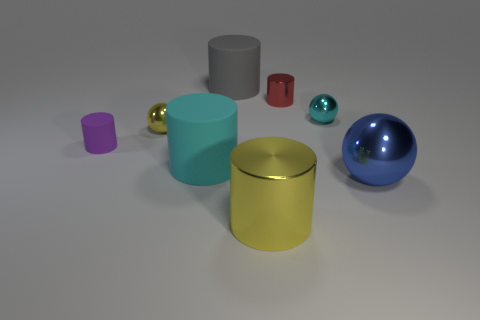Does the cyan rubber thing have the same size as the gray matte cylinder?
Give a very brief answer. Yes. The small metallic ball that is right of the metal cylinder that is behind the large rubber thing that is in front of the purple thing is what color?
Your answer should be compact. Cyan. What number of tiny objects are the same color as the tiny rubber cylinder?
Your answer should be very brief. 0. How many large objects are shiny cylinders or blue metallic objects?
Provide a short and direct response. 2. Is there another big shiny object of the same shape as the big gray thing?
Give a very brief answer. Yes. Is the big blue shiny thing the same shape as the tiny yellow metal thing?
Your answer should be compact. Yes. What color is the thing that is in front of the big metal object that is right of the cyan metal ball?
Your response must be concise. Yellow. There is a metallic cylinder that is the same size as the blue thing; what is its color?
Provide a short and direct response. Yellow. What number of rubber objects are large purple blocks or red objects?
Offer a very short reply. 0. There is a large shiny thing that is on the left side of the small red thing; how many tiny balls are right of it?
Your response must be concise. 1. 